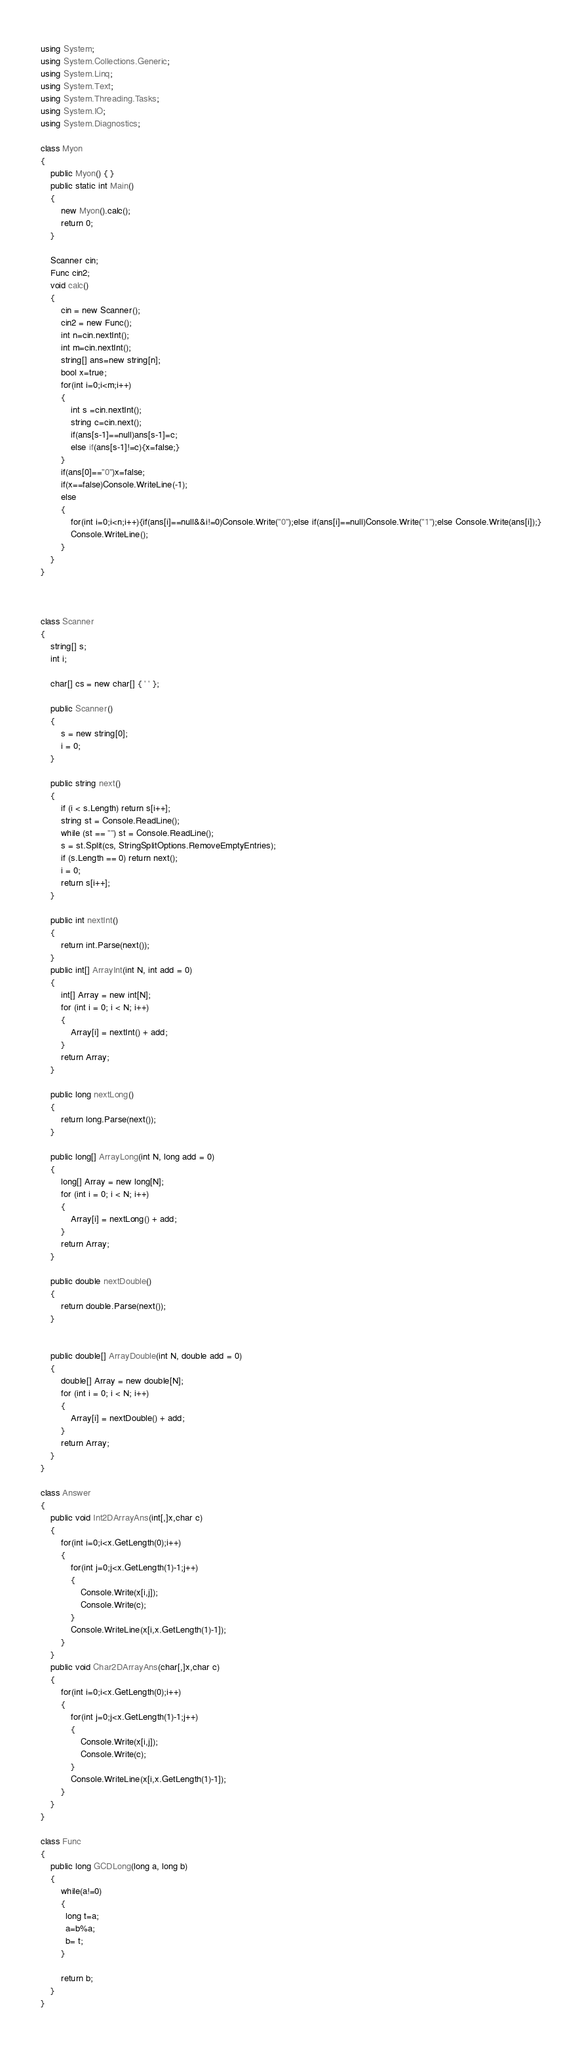Convert code to text. <code><loc_0><loc_0><loc_500><loc_500><_C#_>using System;
using System.Collections.Generic;
using System.Linq;
using System.Text;
using System.Threading.Tasks;
using System.IO;
using System.Diagnostics;

class Myon
{
    public Myon() { }
    public static int Main()
    {
        new Myon().calc();
        return 0;
    }

    Scanner cin;
    Func cin2;
    void calc()
    {
        cin = new Scanner();
        cin2 = new Func();
        int n=cin.nextInt();
        int m=cin.nextInt();
        string[] ans=new string[n];
        bool x=true;
        for(int i=0;i<m;i++)
        {
            int s =cin.nextInt();
            string c=cin.next();
            if(ans[s-1]==null)ans[s-1]=c;
            else if(ans[s-1]!=c){x=false;}
        }
        if(ans[0]=="0")x=false;
        if(x==false)Console.WriteLine(-1);
        else
        {
            for(int i=0;i<n;i++){if(ans[i]==null&&i!=0)Console.Write("0");else if(ans[i]==null)Console.Write("1");else Console.Write(ans[i]);}
            Console.WriteLine();
        }
    }
}



class Scanner
{
    string[] s;
    int i;

    char[] cs = new char[] { ' ' };

    public Scanner()
    {
        s = new string[0];
        i = 0;
    }

    public string next()
    {
        if (i < s.Length) return s[i++];
        string st = Console.ReadLine();
        while (st == "") st = Console.ReadLine();
        s = st.Split(cs, StringSplitOptions.RemoveEmptyEntries);
        if (s.Length == 0) return next();
        i = 0;
        return s[i++];
    }

    public int nextInt()
    {
        return int.Parse(next());
    }
    public int[] ArrayInt(int N, int add = 0)
    {
        int[] Array = new int[N];
        for (int i = 0; i < N; i++)
        {
            Array[i] = nextInt() + add;
        }
        return Array;
    }

    public long nextLong()
    {
        return long.Parse(next());
    }

    public long[] ArrayLong(int N, long add = 0)
    {
        long[] Array = new long[N];
        for (int i = 0; i < N; i++)
        {
            Array[i] = nextLong() + add;
        }
        return Array;
    }

    public double nextDouble()
    {
        return double.Parse(next());
    }


    public double[] ArrayDouble(int N, double add = 0)
    {
        double[] Array = new double[N];
        for (int i = 0; i < N; i++)
        {
            Array[i] = nextDouble() + add;
        }
        return Array;
    }
}

class Answer
{
    public void Int2DArrayAns(int[,]x,char c)
    {
        for(int i=0;i<x.GetLength(0);i++)
        {
            for(int j=0;j<x.GetLength(1)-1;j++)
            {
                Console.Write(x[i,j]);
                Console.Write(c);
            }
            Console.WriteLine(x[i,x.GetLength(1)-1]);
        }
    }
    public void Char2DArrayAns(char[,]x,char c)
    {
        for(int i=0;i<x.GetLength(0);i++)
        {
            for(int j=0;j<x.GetLength(1)-1;j++)
            {
                Console.Write(x[i,j]);
                Console.Write(c);
            }
            Console.WriteLine(x[i,x.GetLength(1)-1]);
        }
    }
}

class Func
{
    public long GCDLong(long a, long b)
    {
        while(a!=0)
        {
          long t=a;
          a=b%a;
          b= t;
        }
      
        return b;        
    }
}</code> 